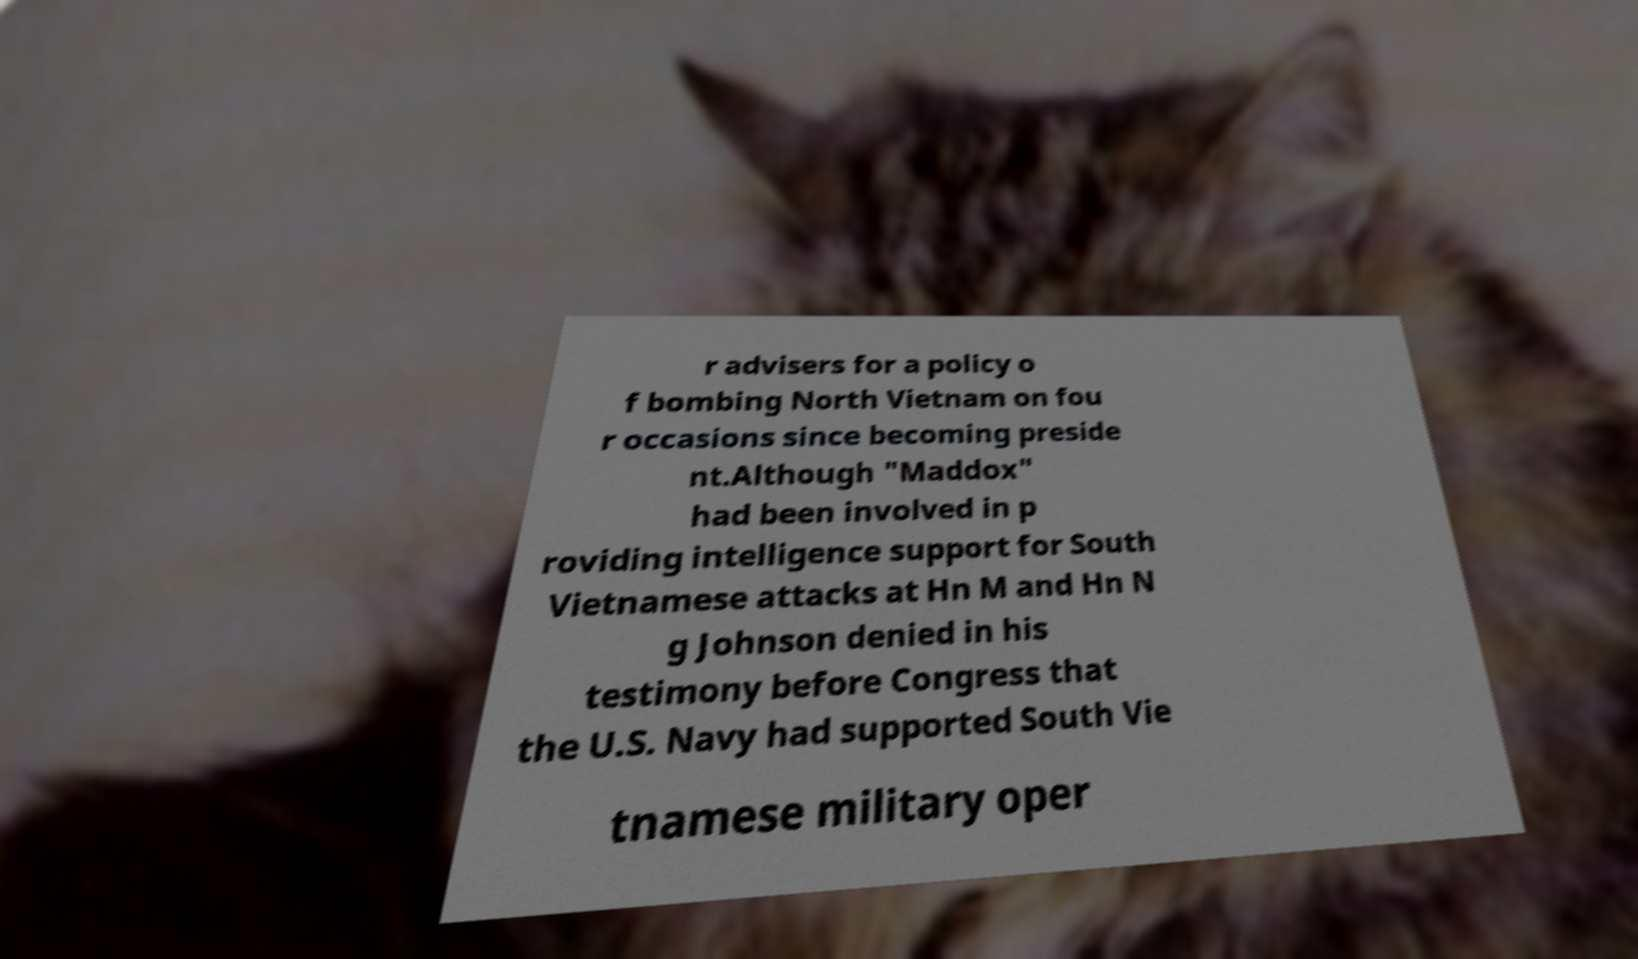Can you accurately transcribe the text from the provided image for me? r advisers for a policy o f bombing North Vietnam on fou r occasions since becoming preside nt.Although "Maddox" had been involved in p roviding intelligence support for South Vietnamese attacks at Hn M and Hn N g Johnson denied in his testimony before Congress that the U.S. Navy had supported South Vie tnamese military oper 